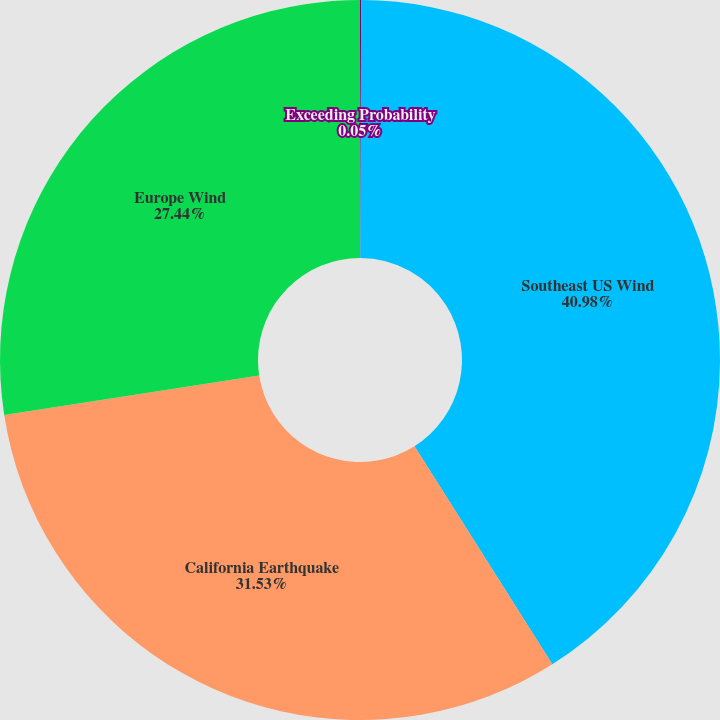Convert chart to OTSL. <chart><loc_0><loc_0><loc_500><loc_500><pie_chart><fcel>Exceeding Probability<fcel>Southeast US Wind<fcel>California Earthquake<fcel>Europe Wind<nl><fcel>0.05%<fcel>40.98%<fcel>31.53%<fcel>27.44%<nl></chart> 